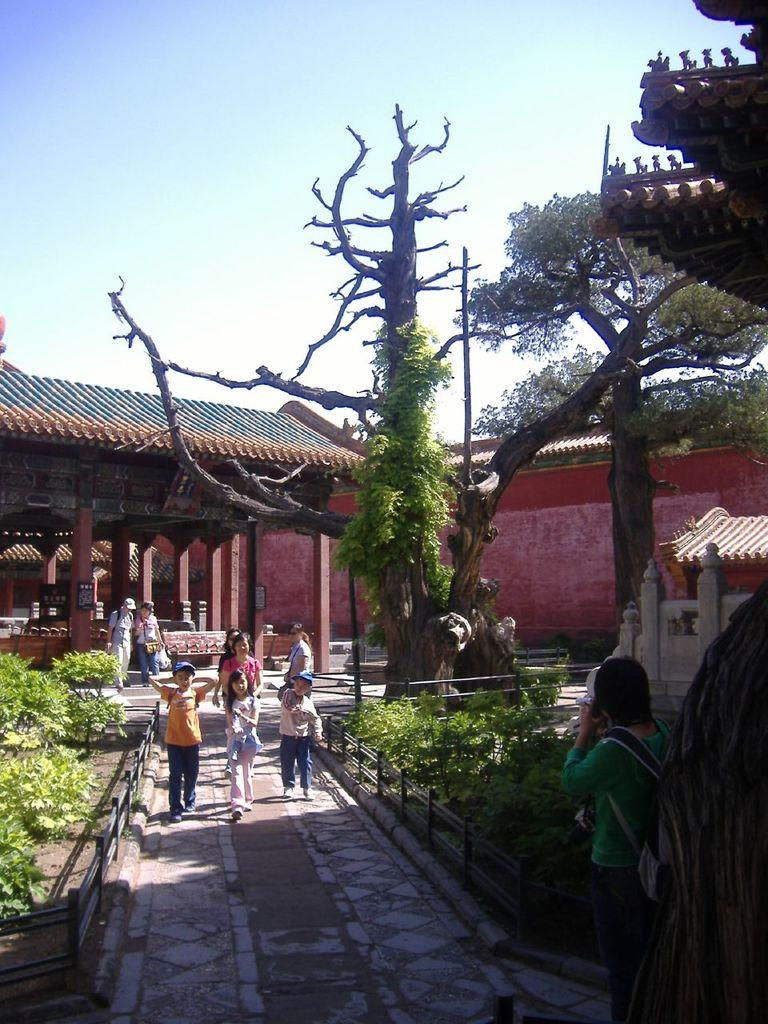What type of structures can be seen in the image? There are houses in the image. What other natural elements are present in the image? There are plants and trees visible in the image. Are there any living beings in the image? Yes, there are people visible in the image. What is visible in the background of the image? The sky is visible in the image. Can you describe the creaminess of the park in the image? There is no park present in the image, and therefore no creaminess can be described. 